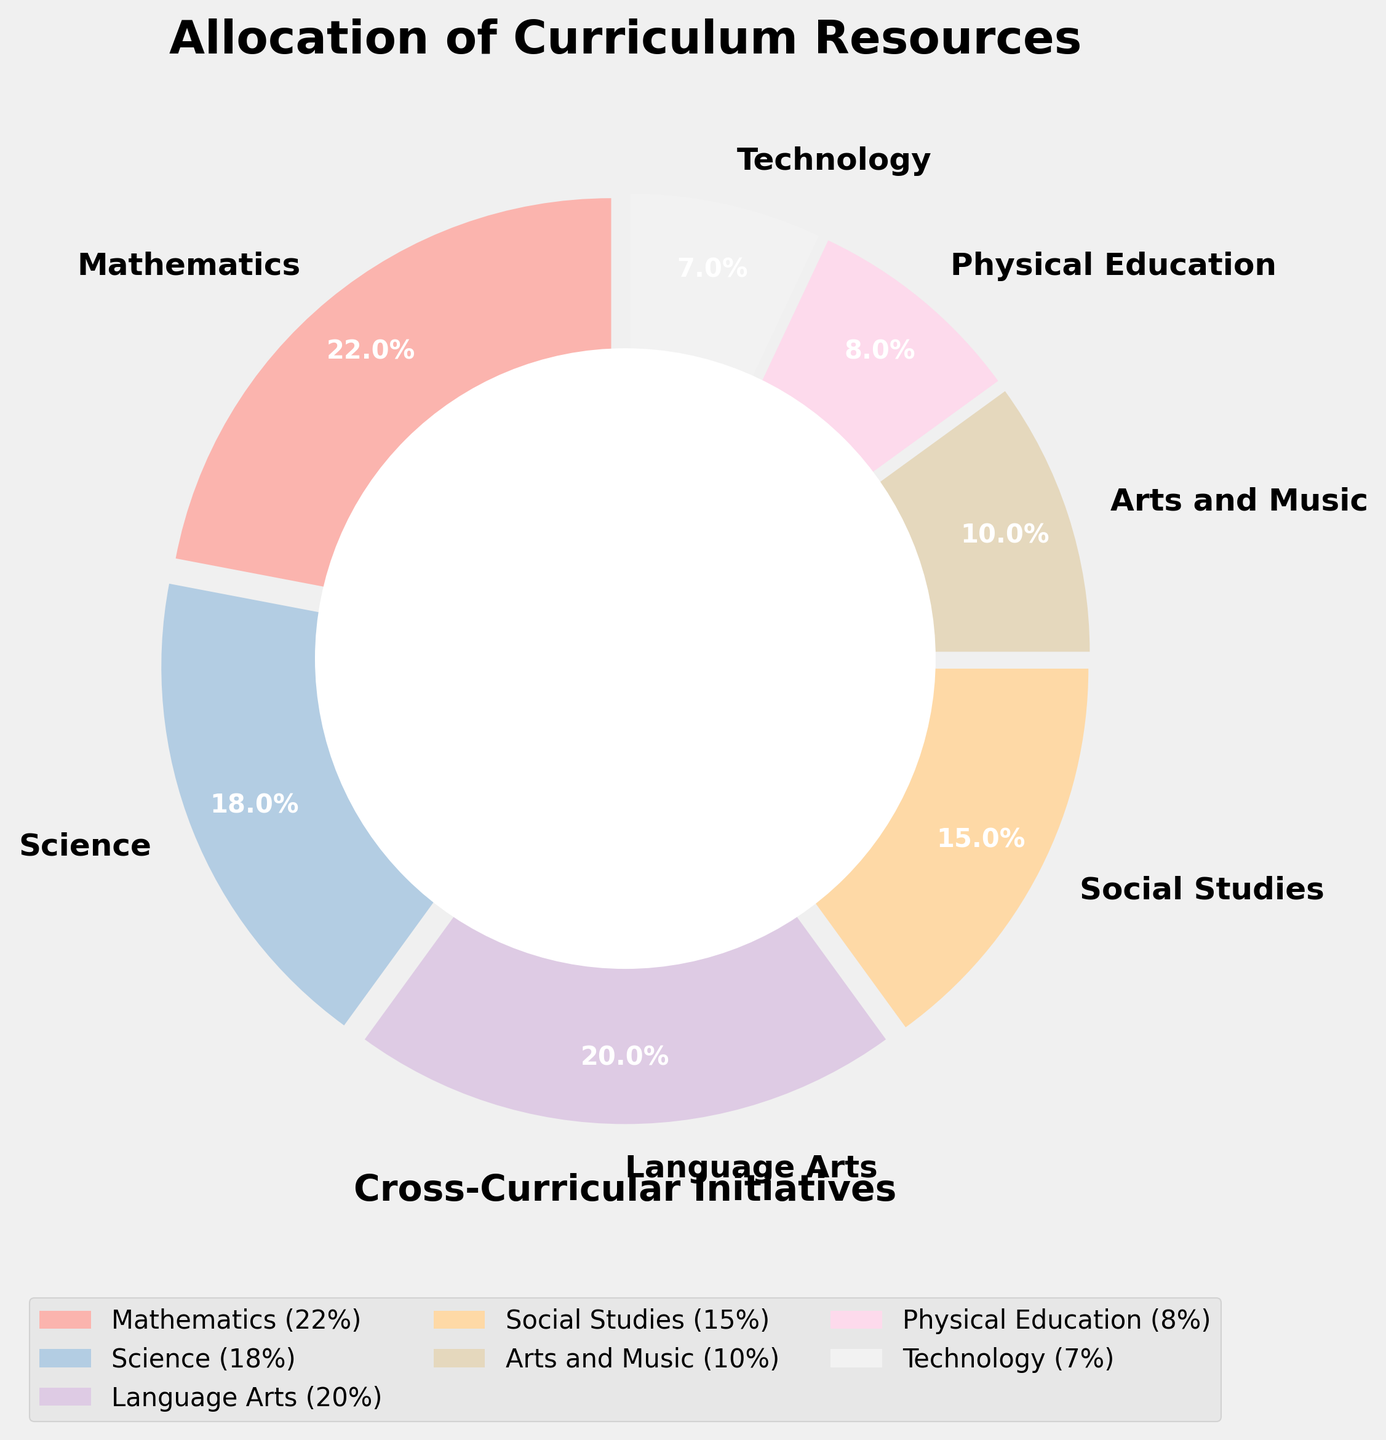Which subject area receives the highest allocation of resources? The pie chart shows that Mathematics has the largest slice, corresponding to 22%.
Answer: Mathematics What is the difference in resource allocation between Science and Technology? The pie chart indicates that Science has 18% and Technology has 7%. The difference is 18% - 7%.
Answer: 11% How many subjects have an allocation of 15% or higher? The pie chart slices for Mathematics (22%), Science (18%), Language Arts (20%), and Social Studies (15%). There are 4 subjects meeting the criteria.
Answer: 4 Which subject area receives nearly half of the resources of Language Arts? Language Arts has 20%, and approximately half of 20% is 10%. The only slice close to this value is for Arts and Music.
Answer: Arts and Music Is the resource allocation for Physical Education greater than or equal to Technology? Observing the pie chart, Physical Education has 8% while Technology has 7%. Physical Education is indeed greater than Technology.
Answer: Yes What is the combined allocation percentage for Arts and Music, and Physical Education? The pie chart reveals that Arts and Music has 10% and Physical Education has 8%. Adding them together gives 10% + 8%.
Answer: 18% Which subject's resource allocation is closest in value to the overall average allocation? To find the average, we sum the percentages and divide by the number of subjects: (22 + 18 + 20 + 15 + 10 + 8 + 7) / 7 = 100 / 7 ≈ 14.3%. The closest allocation percentage to this is Social Studies with 15%.
Answer: Social Studies How many subject areas have smaller allocations than Language Arts but more than Technology? Language Arts has 20%. Subjects smaller than 20% but more than 7% (Technology) are Science (18%), Social Studies (15%), Arts and Music (10%), Physical Education (8%). There are 4 such subjects.
Answer: 4 What is the relative visual size of the slice for the subject with the least resource allocation? The smallest slice in the pie chart is Technology, indicated by its 7% allocation. Its slice is visually the smallest compared to others.
Answer: Smallest Which subject areas have an allocation difference of 5%? By comparing slices, Mathematics (22%) vs. Language Arts (20%) differs by 2%, Science (18%) vs. Social Studies (15%) differs by 3%. Social Studies (15%) vs Arts and Music (10%) differs by 5%.
Answer: Social Studies and Arts and Music 